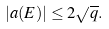<formula> <loc_0><loc_0><loc_500><loc_500>| a ( E ) | \leq 2 \sqrt { q } .</formula> 